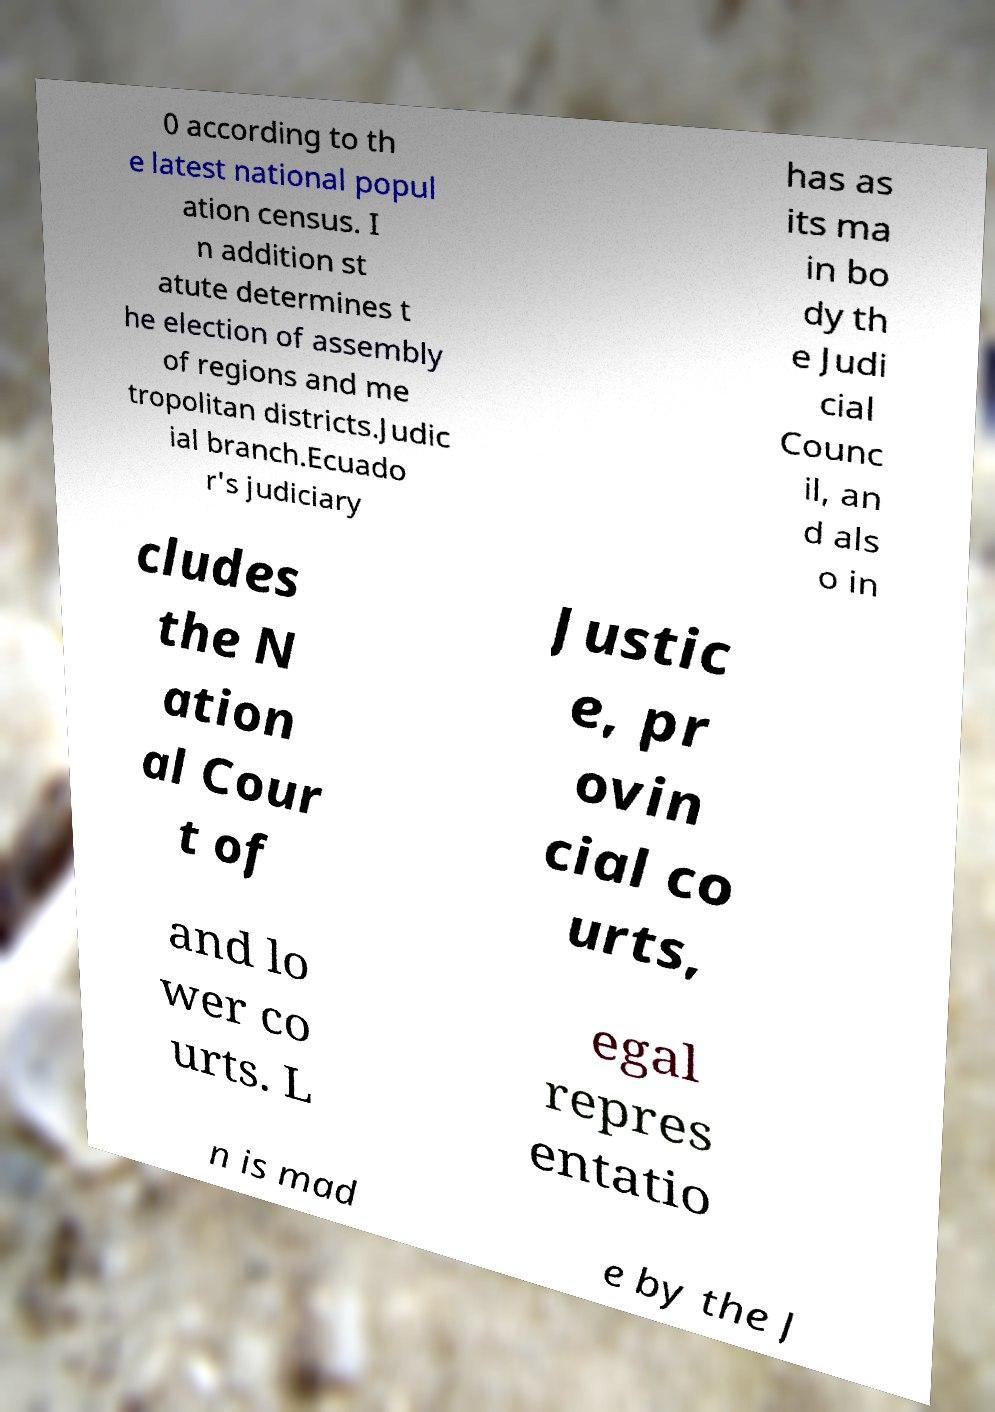Please read and relay the text visible in this image. What does it say? 0 according to th e latest national popul ation census. I n addition st atute determines t he election of assembly of regions and me tropolitan districts.Judic ial branch.Ecuado r's judiciary has as its ma in bo dy th e Judi cial Counc il, an d als o in cludes the N ation al Cour t of Justic e, pr ovin cial co urts, and lo wer co urts. L egal repres entatio n is mad e by the J 